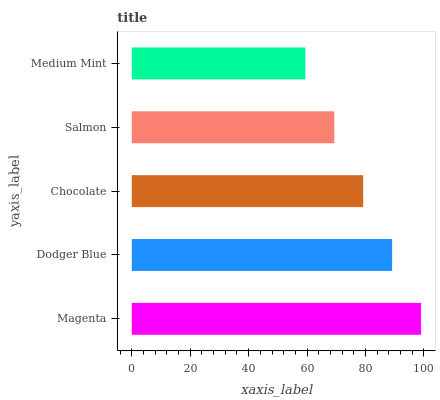Is Medium Mint the minimum?
Answer yes or no. Yes. Is Magenta the maximum?
Answer yes or no. Yes. Is Dodger Blue the minimum?
Answer yes or no. No. Is Dodger Blue the maximum?
Answer yes or no. No. Is Magenta greater than Dodger Blue?
Answer yes or no. Yes. Is Dodger Blue less than Magenta?
Answer yes or no. Yes. Is Dodger Blue greater than Magenta?
Answer yes or no. No. Is Magenta less than Dodger Blue?
Answer yes or no. No. Is Chocolate the high median?
Answer yes or no. Yes. Is Chocolate the low median?
Answer yes or no. Yes. Is Magenta the high median?
Answer yes or no. No. Is Salmon the low median?
Answer yes or no. No. 